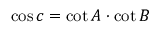Convert formula to latex. <formula><loc_0><loc_0><loc_500><loc_500>\cos c = \cot A \cdot \cot B</formula> 